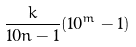<formula> <loc_0><loc_0><loc_500><loc_500>\frac { k } { 1 0 n - 1 } ( 1 0 ^ { m } - 1 )</formula> 